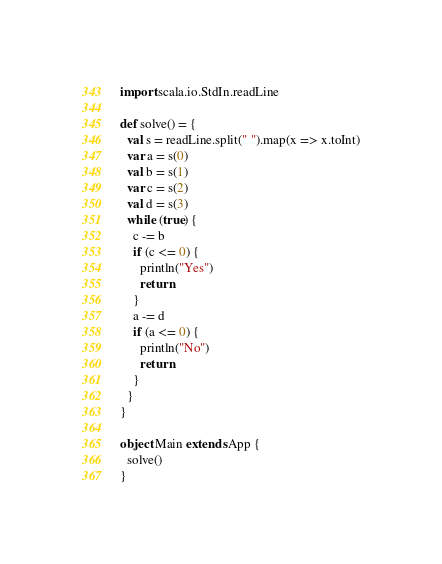<code> <loc_0><loc_0><loc_500><loc_500><_Scala_>import scala.io.StdIn.readLine

def solve() = {
  val s = readLine.split(" ").map(x => x.toInt)
  var a = s(0)
  val b = s(1)
  var c = s(2)
  val d = s(3)
  while (true) {
    c -= b
    if (c <= 0) {
      println("Yes")
      return
    }
    a -= d
    if (a <= 0) {
      println("No")
      return
    }
  }
}

object Main extends App {
  solve()
}
</code> 